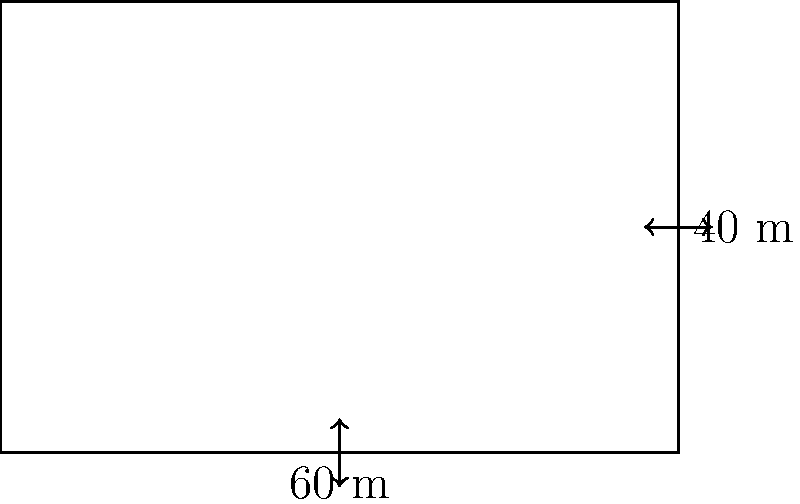You want to fence a rectangular pasture for your livestock. The pasture measures 60 meters in length and 40 meters in width. If you need to leave a 5-meter-wide gate on one of the shorter sides, how many meters of fencing will you need to enclose the entire pasture? To solve this problem, let's break it down into steps:

1. Calculate the perimeter of the rectangle:
   $$ \text{Perimeter} = 2 \times (\text{length} + \text{width}) $$
   $$ \text{Perimeter} = 2 \times (60 \text{ m} + 40 \text{ m}) = 2 \times 100 \text{ m} = 200 \text{ m} $$

2. Subtract the width of the gate from the total perimeter:
   $$ \text{Fencing needed} = \text{Perimeter} - \text{Gate width} $$
   $$ \text{Fencing needed} = 200 \text{ m} - 5 \text{ m} = 195 \text{ m} $$

Therefore, you will need 195 meters of fencing to enclose the pasture while leaving space for a 5-meter-wide gate.
Answer: 195 m 